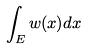Convert formula to latex. <formula><loc_0><loc_0><loc_500><loc_500>\int _ { E } w ( x ) d x</formula> 